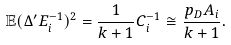<formula> <loc_0><loc_0><loc_500><loc_500>\mathbb { E } ( \Delta ^ { \prime } E ^ { - 1 } _ { i } ) ^ { 2 } = \frac { 1 } { k + 1 } C ^ { - 1 } _ { i } \cong \frac { p _ { D } A _ { i } } { k + 1 } .</formula> 